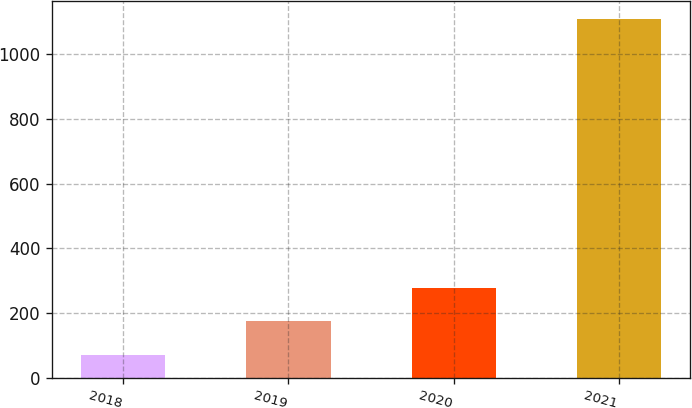<chart> <loc_0><loc_0><loc_500><loc_500><bar_chart><fcel>2018<fcel>2019<fcel>2020<fcel>2021<nl><fcel>71.5<fcel>175.18<fcel>278.86<fcel>1108.3<nl></chart> 